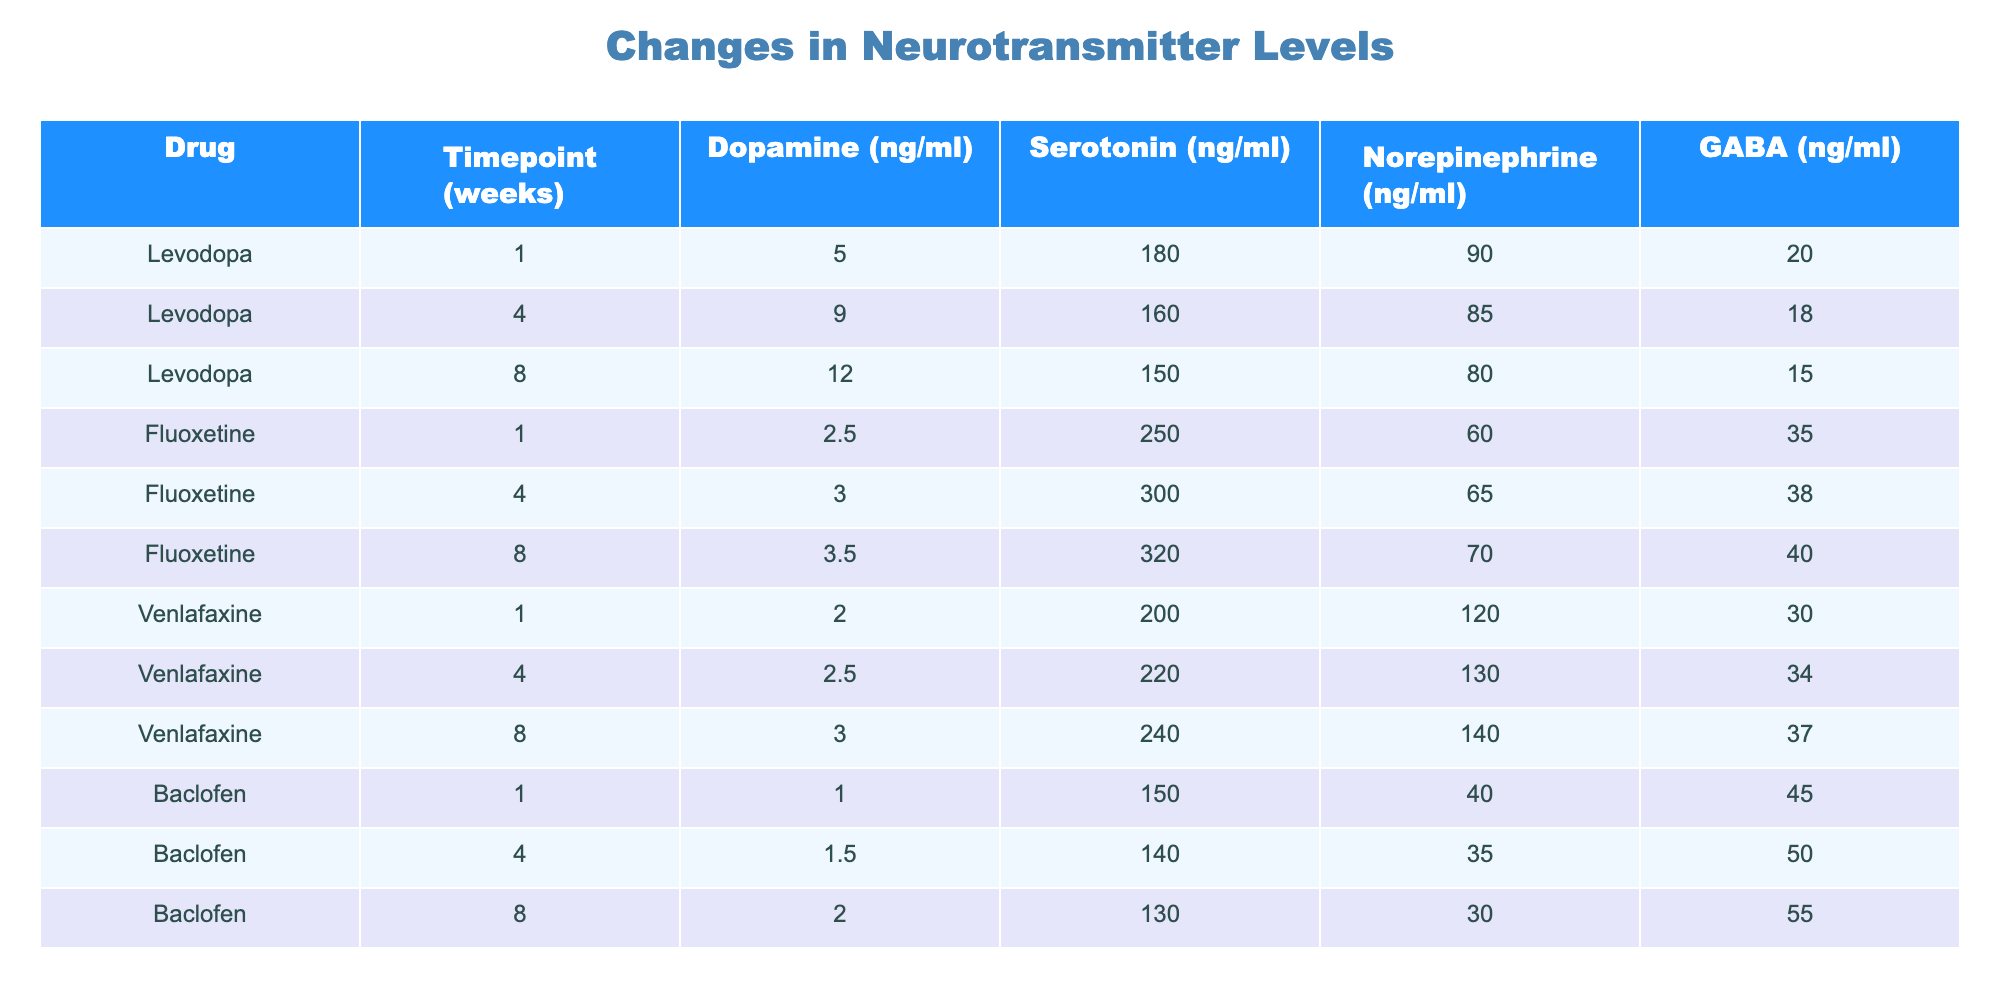What is the level of dopamine after 8 weeks of Levodopa treatment? According to the table, the level of dopamine after 8 weeks of Levodopa treatment is stated directly in the row corresponding to Levodopa and the 8-week timepoint, which shows a value of 12.0 ng/ml.
Answer: 12.0 ng/ml What was the maximum level of serotonin achieved with Fluoxetine, and at what timepoint? By observing the table, the highest value of serotonin for Fluoxetine is at the 8-week timepoint, which is 320 ng/ml.
Answer: 320 ng/ml at 8 weeks Does Baclofen treatment lead to an increase in GABA levels over time? Examining the GABA levels at different timepoints for Baclofen shows consistent increases: 45 ng/ml at 1 week, 50 ng/ml at 4 weeks, and 55 ng/ml at 8 weeks, confirming an overall upward trend.
Answer: Yes What is the average level of norepinephrine across all timepoints for Venlafaxine? To find the average level of norepinephrine for Venlafaxine, first aggregate the levels: (120 + 130 + 140) = 390 ng/ml. Then, divide this by the number of timepoints, which is 3. Therefore, average = 390 / 3 = 130 ng/ml.
Answer: 130 ng/ml Is there a timepoint where the GABA levels for Levodopa fall below those of Baclofen? Comparing GABA levels at the same timepoints shows that Levodopa has GABA values of 20 ng/ml at 1 week, 18 ng/ml at 4 weeks, and 15 ng/ml at 8 weeks, while Baclofen's values are 45, 50, and 55 ng/ml, respectively. Since all GABA levels of Levodopa are below Baclofen's at every timepoint, the answer is yes.
Answer: Yes What is the increase in dopamine levels for Levodopa from the start to the end of the 8-week treatment? The initial dopamine level is 5.0 ng/ml at 1 week, and after 8 weeks, it is 12.0 ng/ml. The increase is calculated by subtracting the initial level from the final level: 12.0 - 5.0 = 7.0 ng/ml.
Answer: 7.0 ng/ml What is the trend in serotonin levels for Fluoxetine over the course of treatment? Reviewing the serotonin levels for Fluoxetine reveals an increasing trend: starting from 250 ng/ml at 1 week, it rises to 300 ng/ml at 4 weeks, and further increases to 320 ng/ml by 8 weeks, indicating sustained growth over time.
Answer: Increasing trend Compare the GABA levels at the end of treatment (8 weeks) for all drugs. Which drug has the highest GABA level? At the 8-week timepoint, the GABA levels are: Levodopa has 15 ng/ml, Fluoxetine has not been recorded (not relevant), Venlafaxine has 37 ng/ml, and Baclofen has 55 ng/ml. Therefore, Baclofen has the highest GABA level at this timepoint.
Answer: Baclofen 